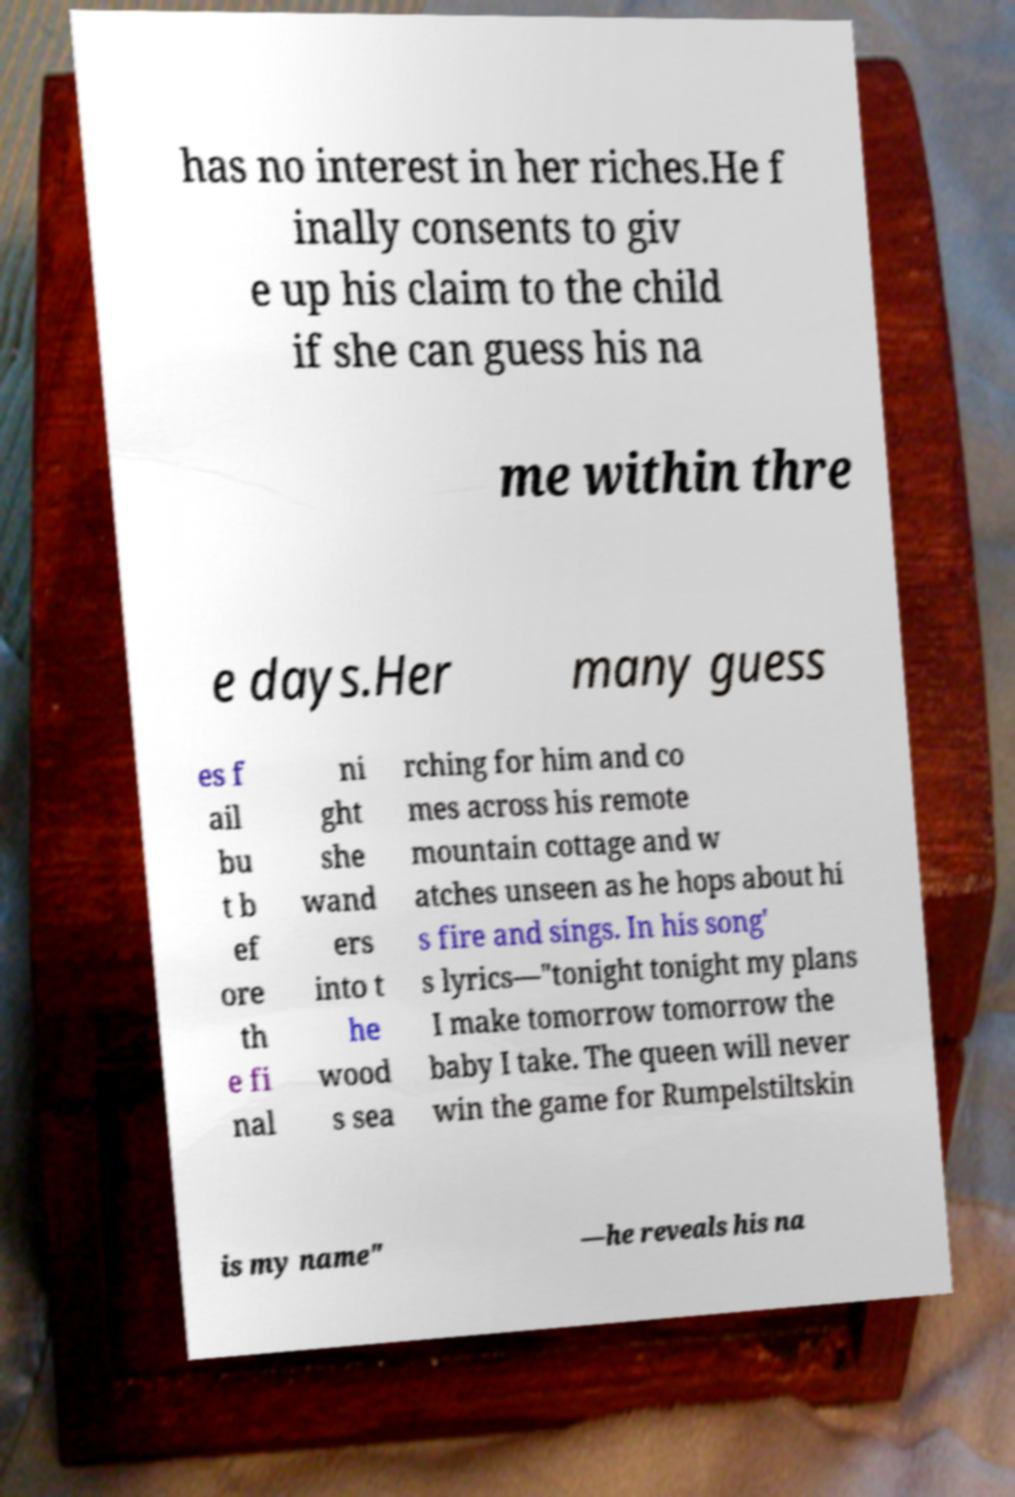Could you assist in decoding the text presented in this image and type it out clearly? has no interest in her riches.He f inally consents to giv e up his claim to the child if she can guess his na me within thre e days.Her many guess es f ail bu t b ef ore th e fi nal ni ght she wand ers into t he wood s sea rching for him and co mes across his remote mountain cottage and w atches unseen as he hops about hi s fire and sings. In his song' s lyrics—"tonight tonight my plans I make tomorrow tomorrow the baby I take. The queen will never win the game for Rumpelstiltskin is my name" —he reveals his na 